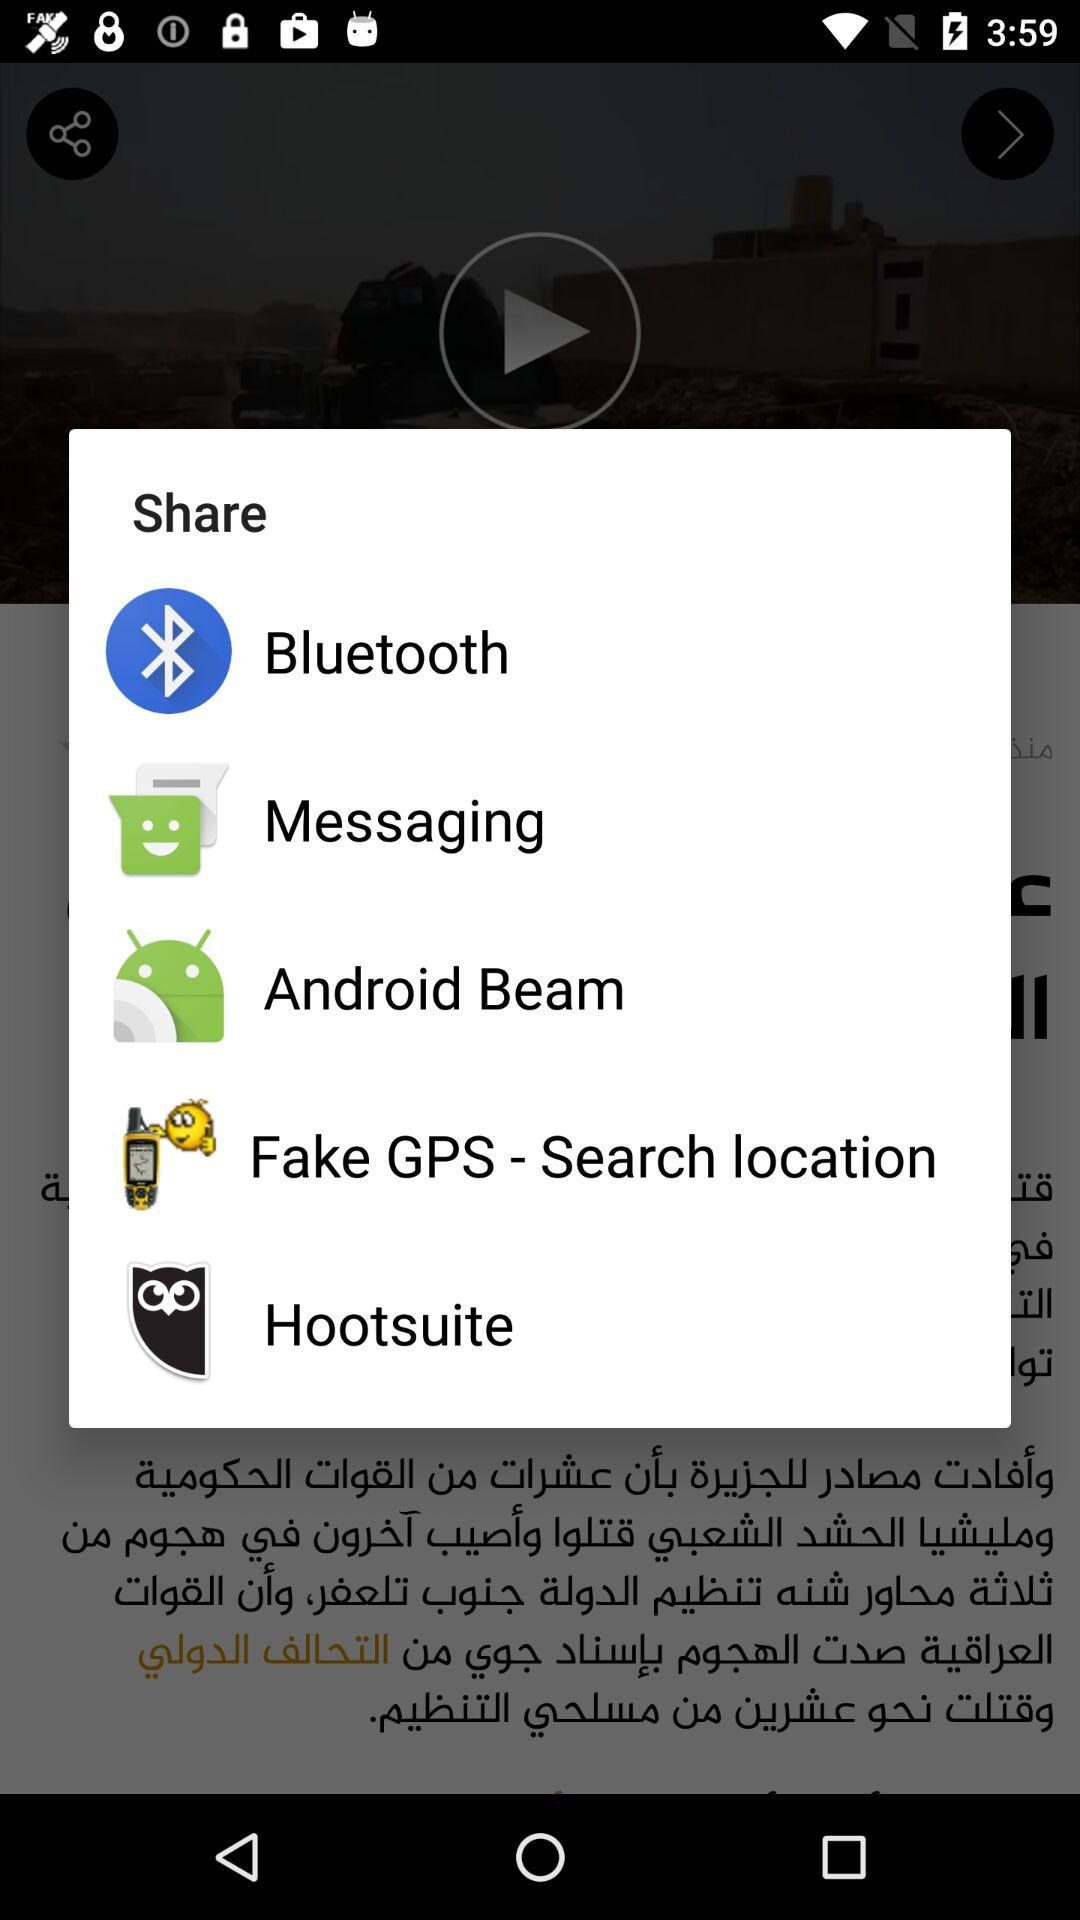How many items are on the share sheet?
Answer the question using a single word or phrase. 5 